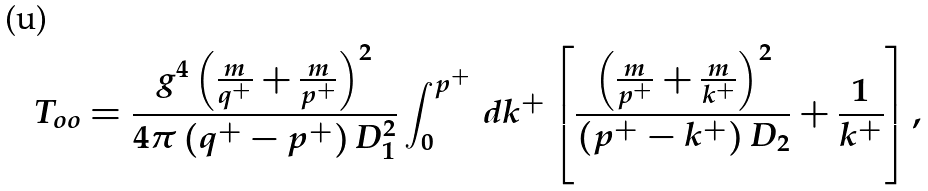<formula> <loc_0><loc_0><loc_500><loc_500>T _ { o o } = \frac { g ^ { 4 } \left ( \frac { m } { q ^ { + } } + \frac { m } { p ^ { + } } \right ) ^ { 2 } } { 4 \pi \left ( q ^ { + } - p ^ { + } \right ) D _ { 1 } ^ { 2 } } \int _ { 0 } ^ { p ^ { + } } \, d k ^ { + } \left [ \frac { \left ( \frac { m } { p ^ { + } } + \frac { m } { k ^ { + } } \right ) ^ { 2 } } { \left ( p ^ { + } - k ^ { + } \right ) D _ { 2 } } + \frac { 1 } { k ^ { + } } \right ] ,</formula> 